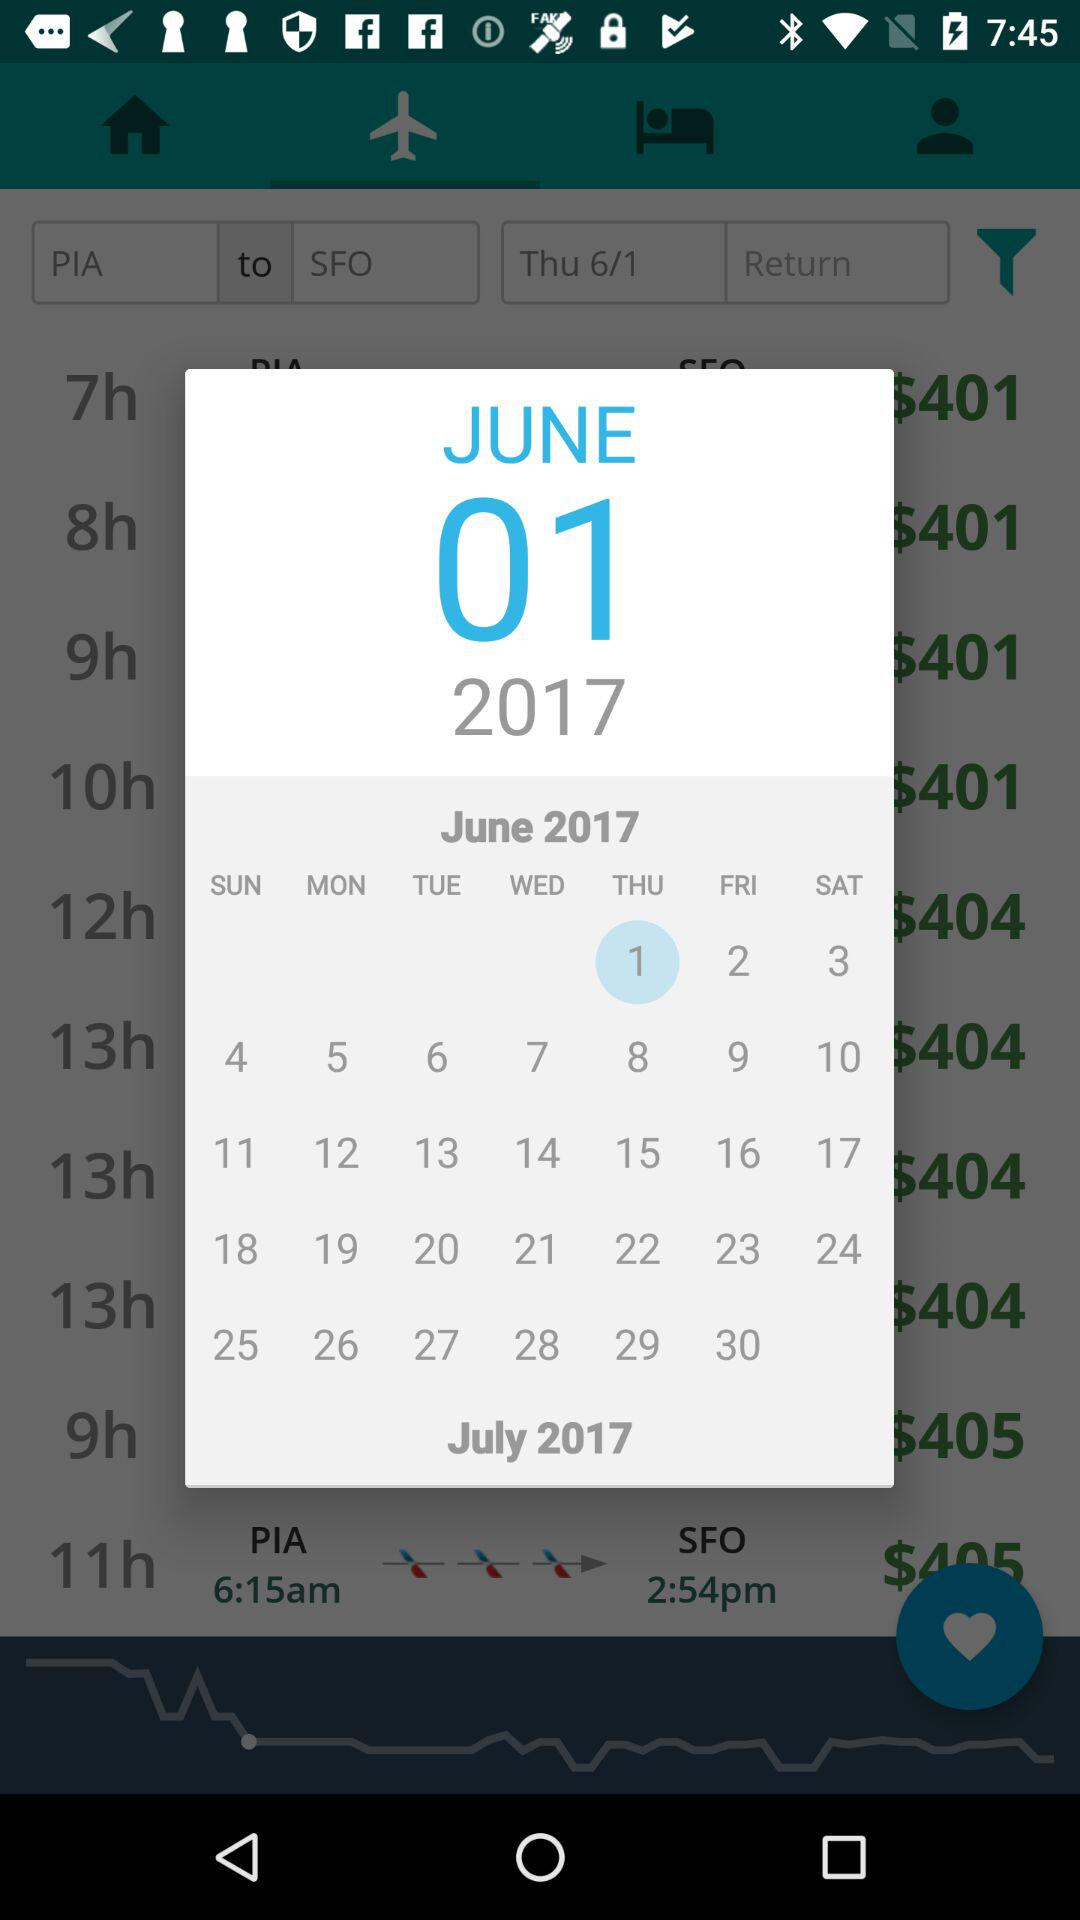What is the arrival airport? The arrival airport is "San Francisco International Airport". 